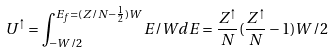Convert formula to latex. <formula><loc_0><loc_0><loc_500><loc_500>U ^ { \uparrow } = \int _ { - W / 2 } ^ { E _ { f } = ( Z / N - \frac { 1 } { 2 } ) W } E / W d E = \frac { Z ^ { \uparrow } } { N } ( \frac { Z ^ { \uparrow } } { N } - 1 ) W / 2</formula> 